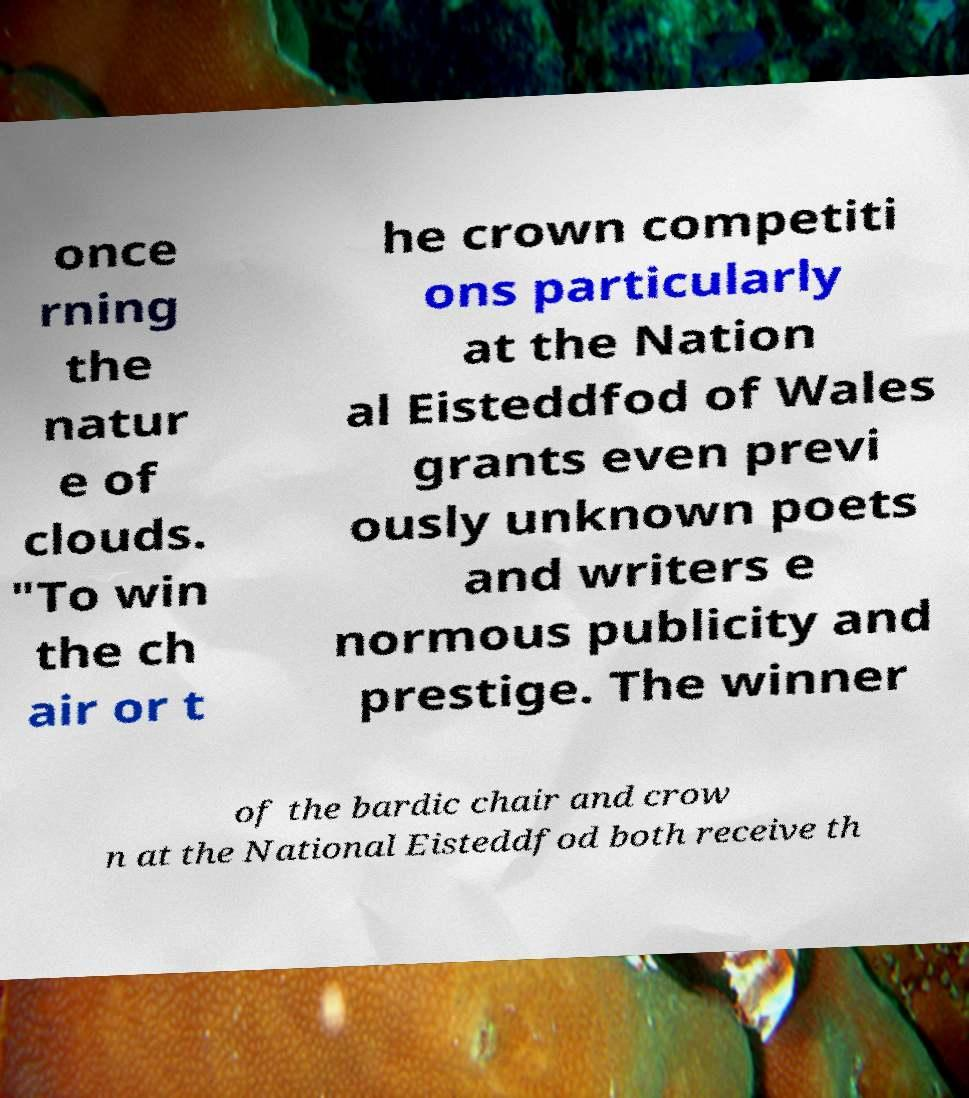I need the written content from this picture converted into text. Can you do that? once rning the natur e of clouds. "To win the ch air or t he crown competiti ons particularly at the Nation al Eisteddfod of Wales grants even previ ously unknown poets and writers e normous publicity and prestige. The winner of the bardic chair and crow n at the National Eisteddfod both receive th 